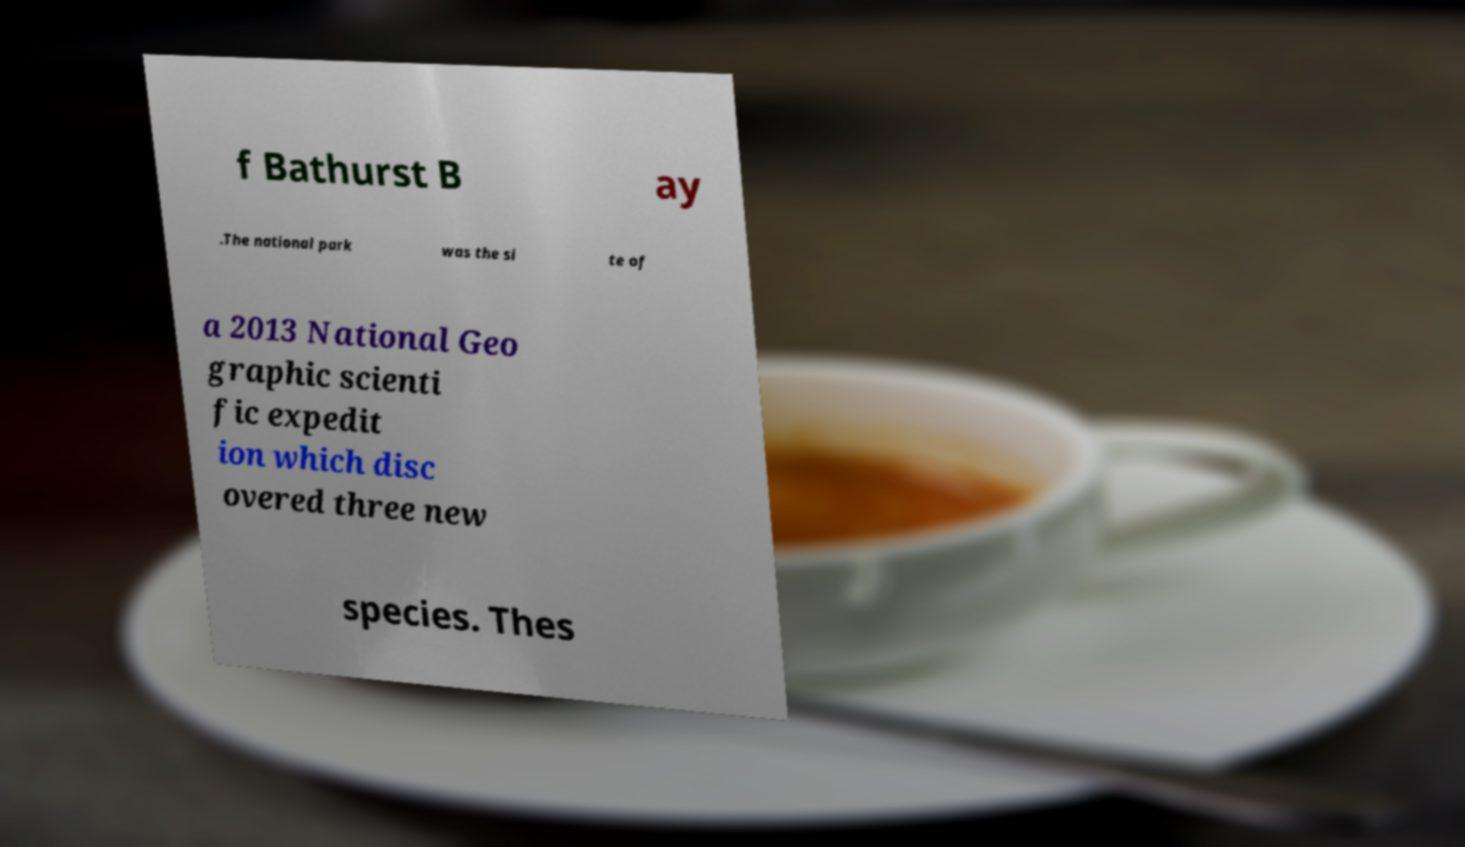Could you extract and type out the text from this image? f Bathurst B ay .The national park was the si te of a 2013 National Geo graphic scienti fic expedit ion which disc overed three new species. Thes 